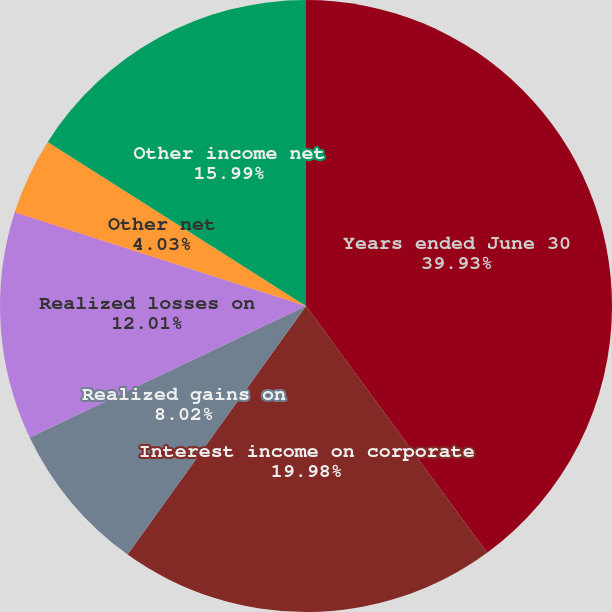Convert chart to OTSL. <chart><loc_0><loc_0><loc_500><loc_500><pie_chart><fcel>Years ended June 30<fcel>Interest income on corporate<fcel>Realized gains on<fcel>Realized losses on<fcel>Net loss (gain) on sales of<fcel>Other net<fcel>Other income net<nl><fcel>39.92%<fcel>19.98%<fcel>8.02%<fcel>12.01%<fcel>0.04%<fcel>4.03%<fcel>15.99%<nl></chart> 